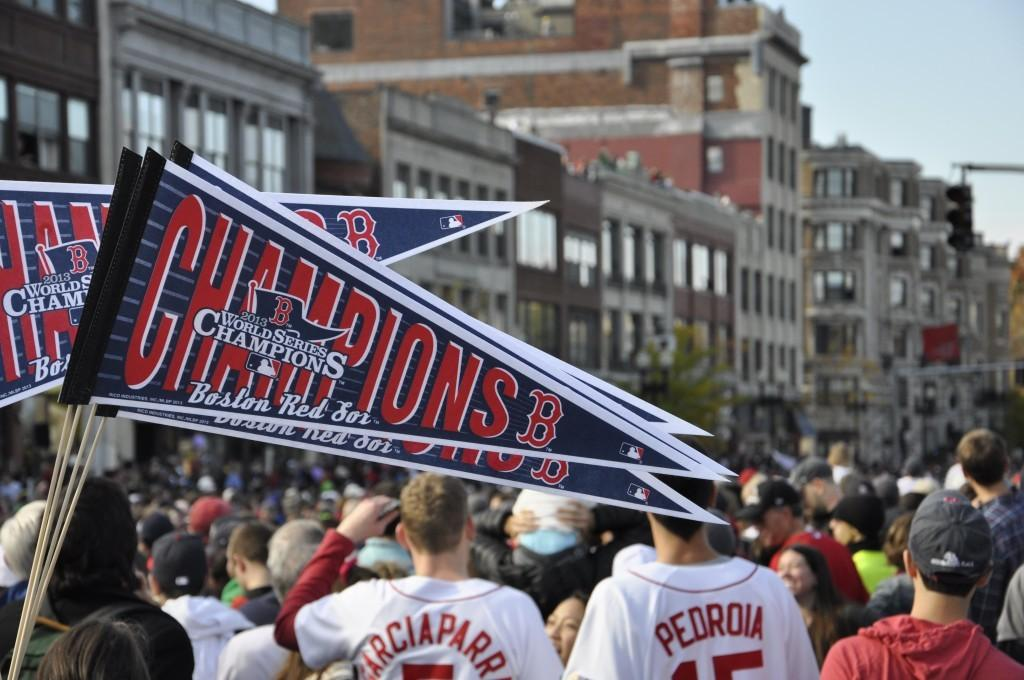Provide a one-sentence caption for the provided image. The game patrons are tailgating for the Boston Red Sox game that will start soon. 